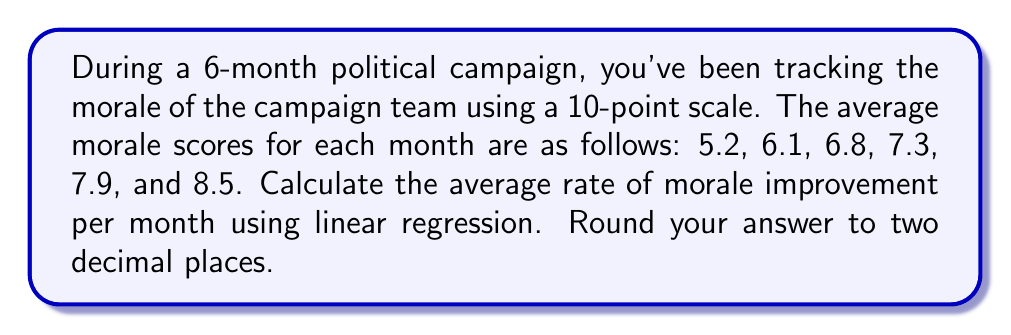Show me your answer to this math problem. To calculate the average rate of morale improvement per month using linear regression, we'll follow these steps:

1) Let's define our variables:
   $x$: months (0, 1, 2, 3, 4, 5)
   $y$: morale scores (5.2, 6.1, 6.8, 7.3, 7.9, 8.5)

2) We need to calculate the slope of the linear regression line, which represents the average rate of improvement per month. The formula for the slope is:

   $$m = \frac{n\sum xy - \sum x \sum y}{n\sum x^2 - (\sum x)^2}$$

   where $n$ is the number of data points (6 in this case).

3) Let's calculate the required sums:
   $\sum x = 0 + 1 + 2 + 3 + 4 + 5 = 15$
   $\sum y = 5.2 + 6.1 + 6.8 + 7.3 + 7.9 + 8.5 = 41.8$
   $\sum xy = 0(5.2) + 1(6.1) + 2(6.8) + 3(7.3) + 4(7.9) + 5(8.5) = 131.3$
   $\sum x^2 = 0^2 + 1^2 + 2^2 + 3^2 + 4^2 + 5^2 = 55$

4) Now, let's substitute these values into our slope formula:

   $$m = \frac{6(131.3) - 15(41.8)}{6(55) - 15^2}$$

5) Simplify:
   $$m = \frac{787.8 - 627}{330 - 225} = \frac{160.8}{105} = 1.53142857...$$

6) Rounding to two decimal places:
   $m \approx 1.53$

Therefore, the average rate of morale improvement is approximately 1.53 points per month.
Answer: 1.53 points/month 